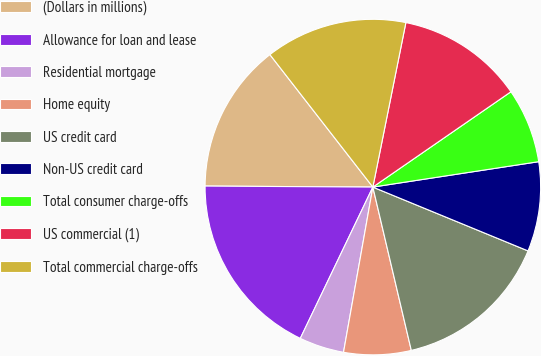Convert chart. <chart><loc_0><loc_0><loc_500><loc_500><pie_chart><fcel>(Dollars in millions)<fcel>Allowance for loan and lease<fcel>Residential mortgage<fcel>Home equity<fcel>US credit card<fcel>Non-US credit card<fcel>Total consumer charge-offs<fcel>US commercial (1)<fcel>Total commercial charge-offs<nl><fcel>14.39%<fcel>17.98%<fcel>4.32%<fcel>6.48%<fcel>15.11%<fcel>8.63%<fcel>7.2%<fcel>12.23%<fcel>13.67%<nl></chart> 